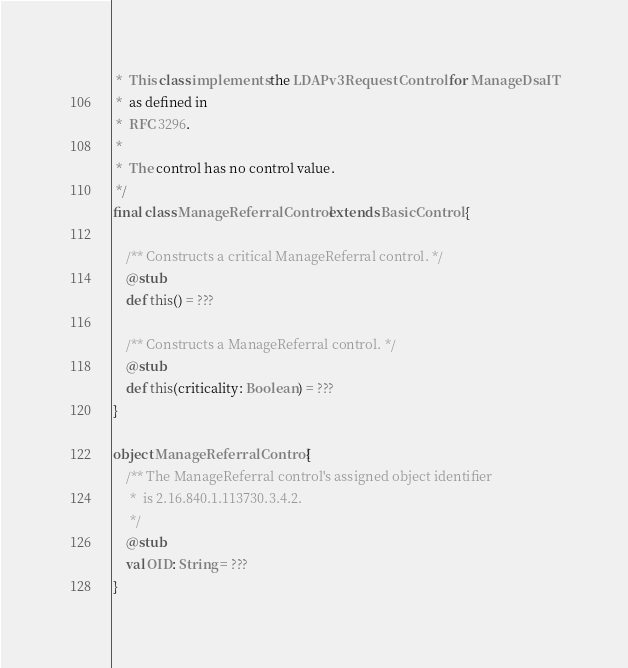<code> <loc_0><loc_0><loc_500><loc_500><_Scala_> *  This class implements the LDAPv3 Request Control for ManageDsaIT
 *  as defined in
 *  RFC 3296.
 * 
 *  The control has no control value.
 */
final class ManageReferralControl extends BasicControl {

    /** Constructs a critical ManageReferral control. */
    @stub
    def this() = ???

    /** Constructs a ManageReferral control. */
    @stub
    def this(criticality: Boolean) = ???
}

object ManageReferralControl {
    /** The ManageReferral control's assigned object identifier
     *  is 2.16.840.1.113730.3.4.2.
     */
    @stub
    val OID: String = ???
}
</code> 